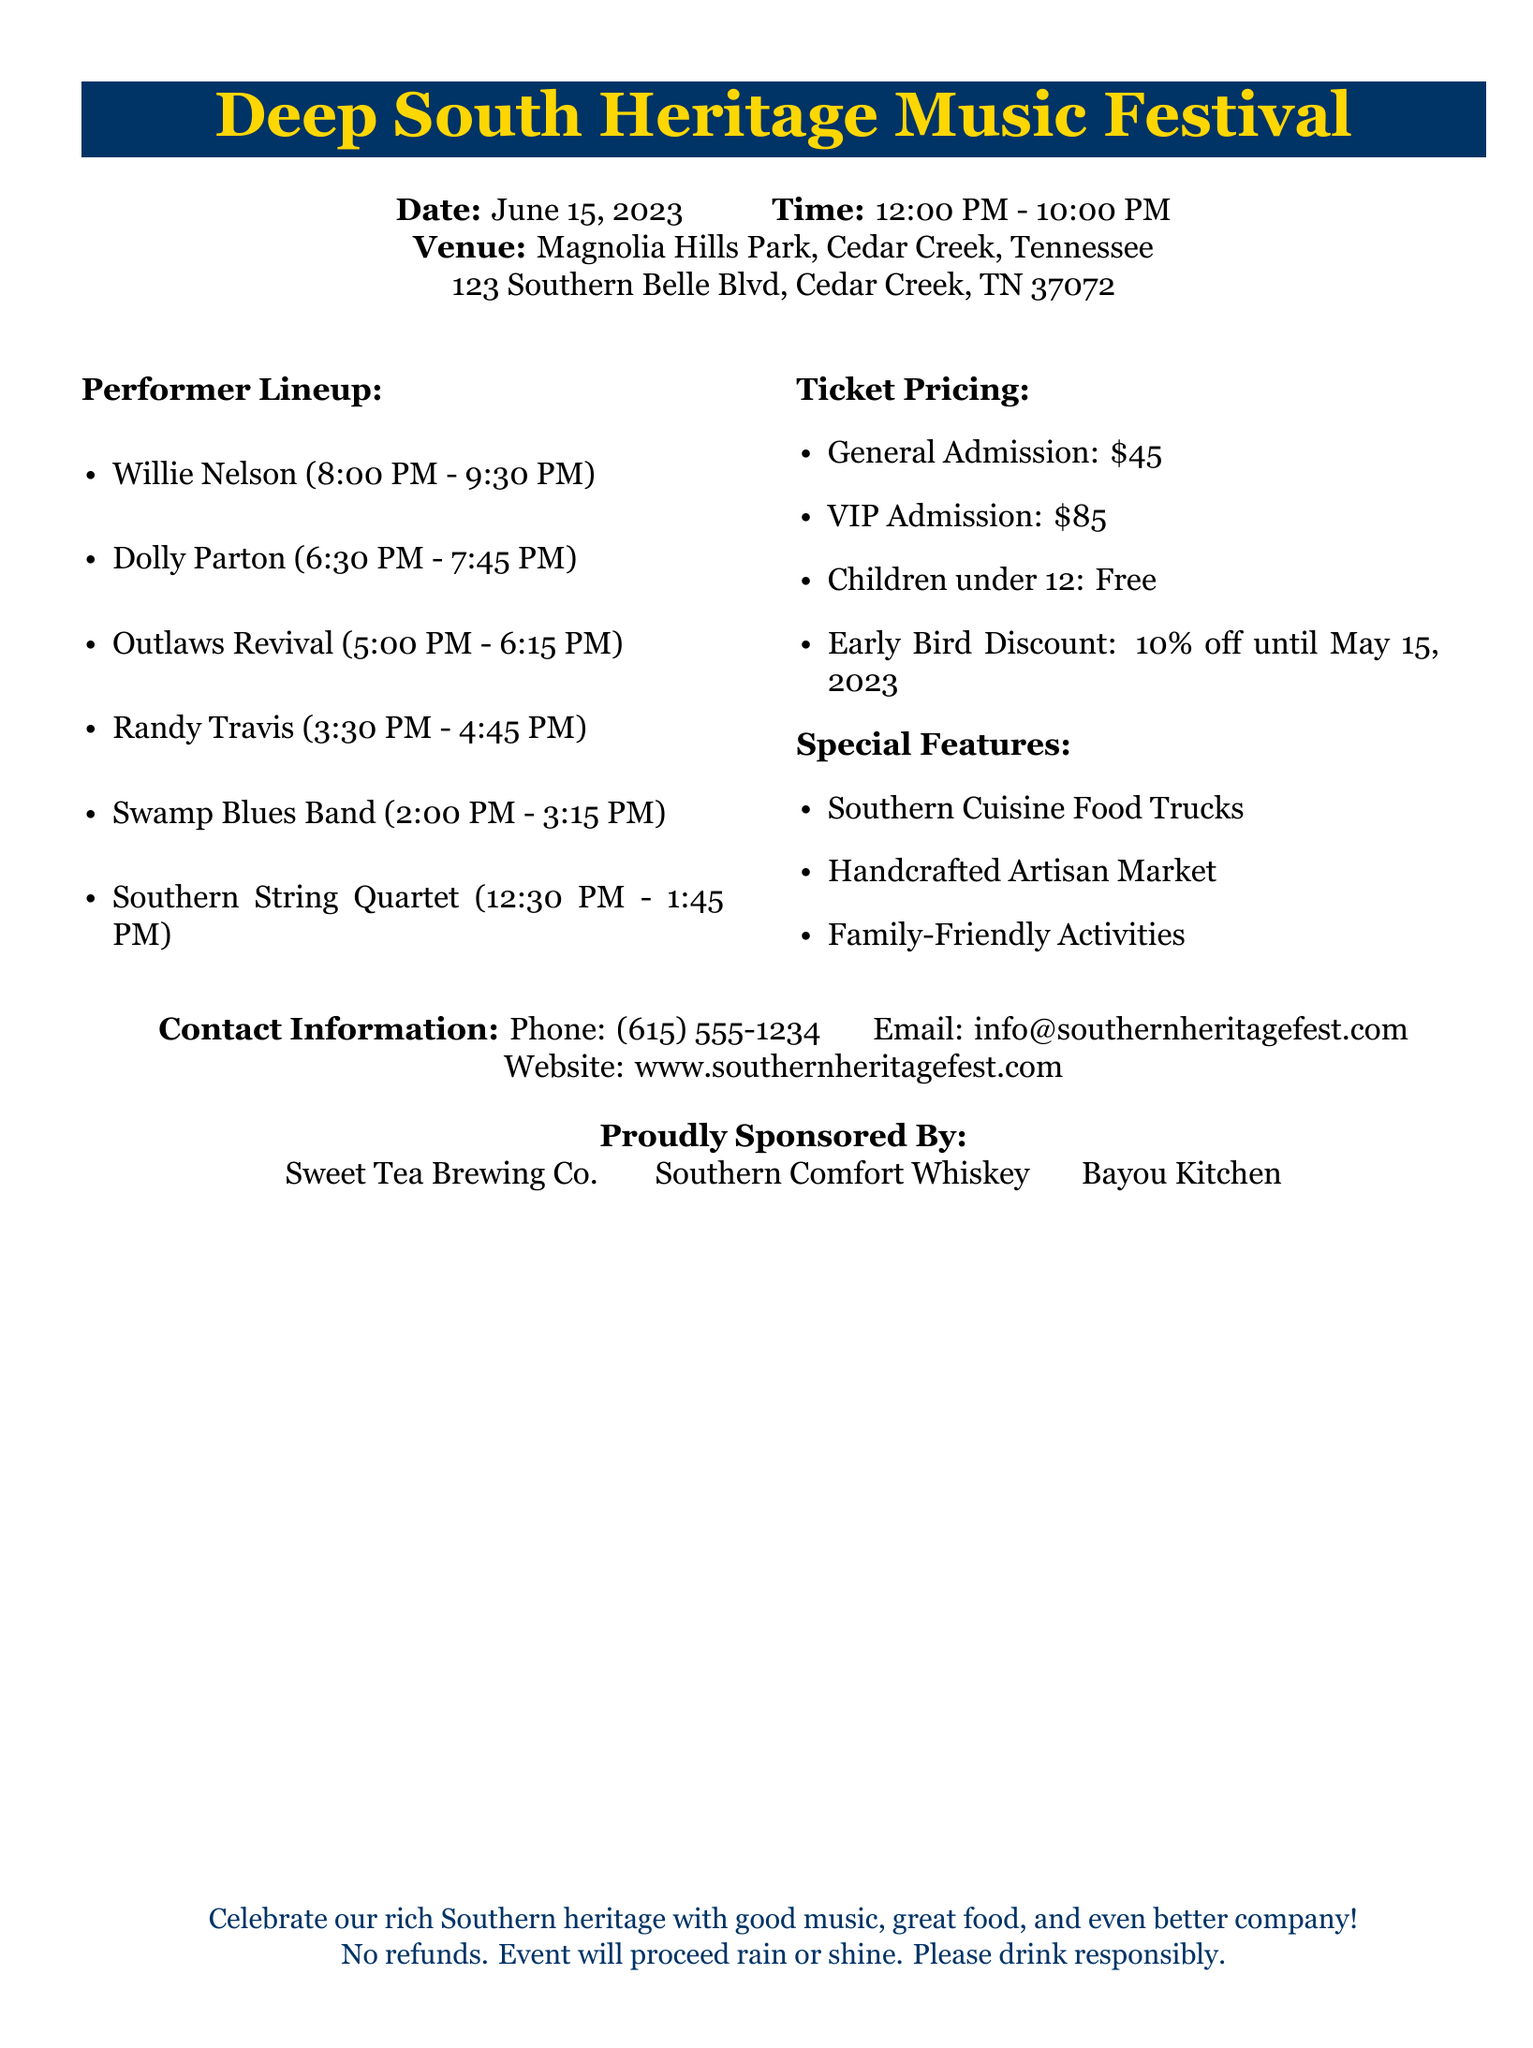What is the name of the festival? The title of the event appears prominently at the top of the document, which is the Deep South Heritage Music Festival.
Answer: Deep South Heritage Music Festival What is the date of the event? The date is clearly stated in the event details section of the document.
Answer: June 15, 2023 What is the venue of the festival? The venue is provided in the same section as the date and time details, making it easy to find.
Answer: Magnolia Hills Park, Cedar Creek, Tennessee Who performs last at the festival? The last performer’s name is listed last in the performer lineup section.
Answer: Willie Nelson What time does the Southern String Quartet perform? The performance time is specified in the performer lineup section of the document.
Answer: 12:30 PM - 1:45 PM How much is general admission? The ticket pricing section states the price for general admission tickets directly.
Answer: $45 Is there an early bird discount? The ticket pricing section mentions specific details about discounts available.
Answer: Yes, 10% off until May 15, 2023 What activities are featured at the festival? The special features section lists activities and highlights at the event.
Answer: Family-Friendly Activities What is the contact phone number for the festival? Contact information, including a phone number, is clearly laid out in the document.
Answer: (615) 555-1234 